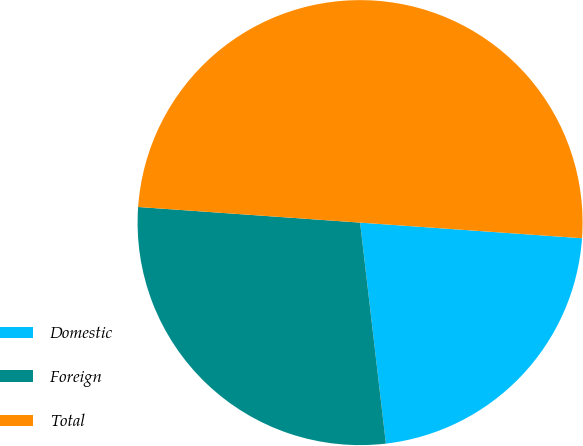<chart> <loc_0><loc_0><loc_500><loc_500><pie_chart><fcel>Domestic<fcel>Foreign<fcel>Total<nl><fcel>22.03%<fcel>27.97%<fcel>50.0%<nl></chart> 